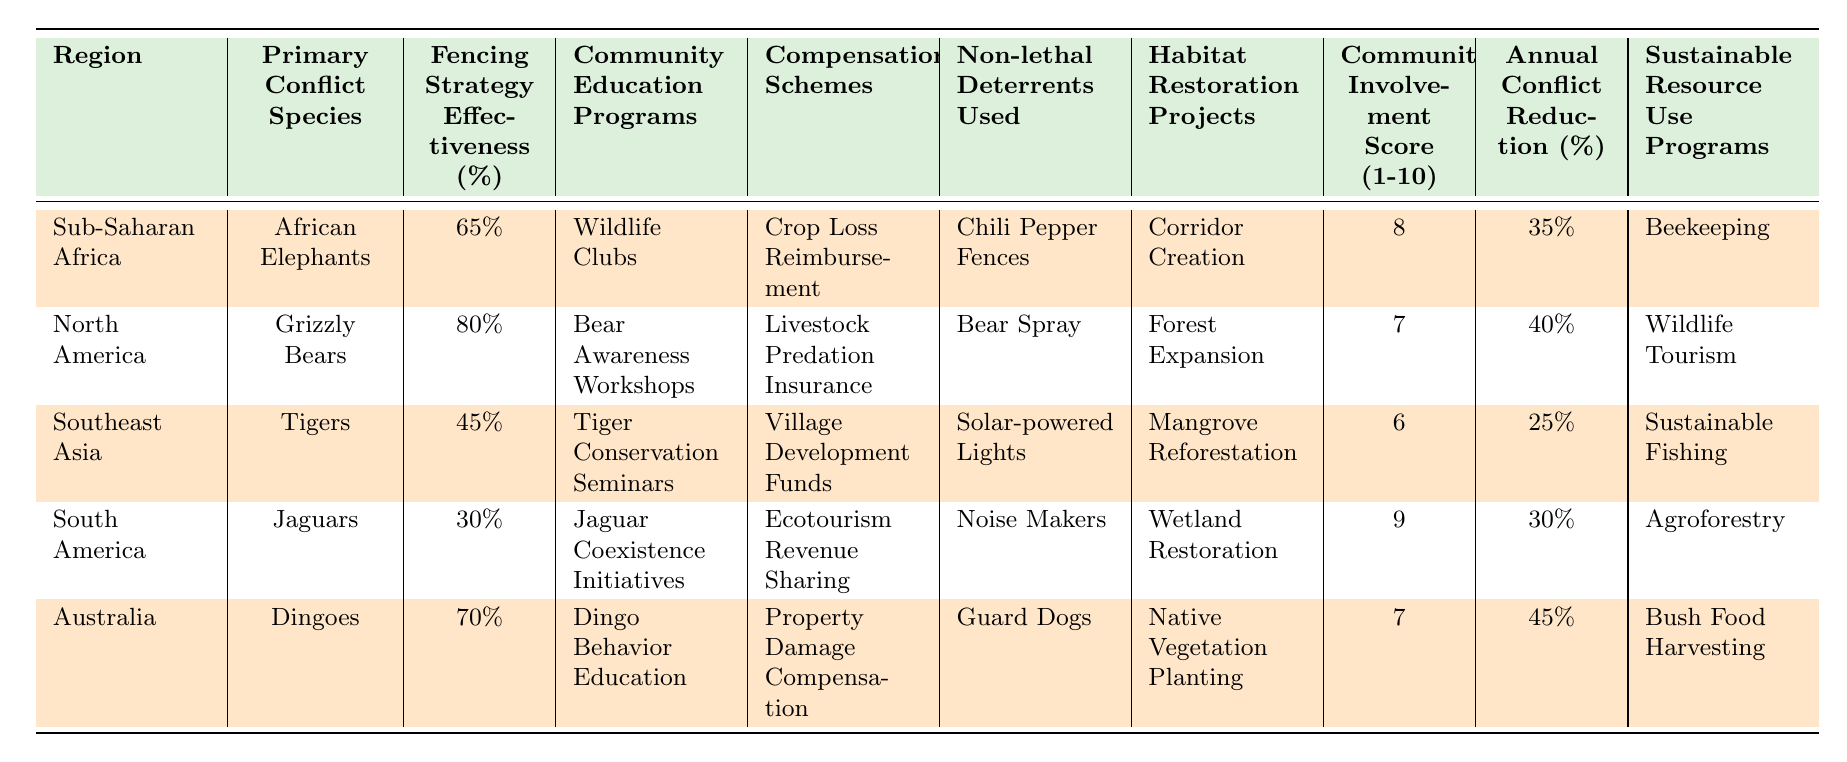What is the primary conflict species in North America? The table lists the primary conflict species for each region. For North America, it shows "Grizzly Bears" as the primary conflict species.
Answer: Grizzly Bears Which region has the highest fencing strategy effectiveness percentage? By comparing the "Fencing Strategy Effectiveness (%)" values, North America has the highest at 80%.
Answer: North America What is the community involvement score for South America? The "Community Involvement Score (1-10)" for South America in the table is given as 9.
Answer: 9 Which region has the lowest annual conflict reduction percentage? The table indicates the "Annual Conflict Reduction (%)" values for each region. Southeast Asia has the lowest at 25%.
Answer: Southeast Asia How many regions report compensation schemes related to ecotourism? In the table, South America is the only region that lists "Ecotourism Revenue Sharing" as its compensation scheme.
Answer: 1 What are the non-lethal deterrents used in Southeast Asia? The table states that Southeast Asia uses "Solar-powered Lights" as its non-lethal deterrent.
Answer: Solar-powered Lights What is the average community involvement score for all regions? Adding the community involvement scores (8 + 7 + 6 + 9 + 7) sums to 37. Dividing by 5 for the average gives 37/5 = 7.4.
Answer: 7.4 Which fencing strategy is used in Australia? The table shows that Australia employs "Guard Dogs" as its non-lethal deterrents, which indicates part of the broader strategy in use.
Answer: Guard Dogs Is "Tiger Conservation Seminars" a community education program in Sub-Saharan Africa? The table shows that "Tiger Conservation Seminars" is listed under Southeast Asia, not Sub-Saharan Africa, making the statement false.
Answer: No How does the effectiveness of fencing strategies correlate with community involvement scores? North America has the highest fencing effectiveness (80%) and a score of 7, while Southeast Asia has the lowest (45%) and a score of 6. A deeper analysis would be needed to explore this correlation further, but it appears less effective in regions with lower community scores.
Answer: Needs deeper analysis 